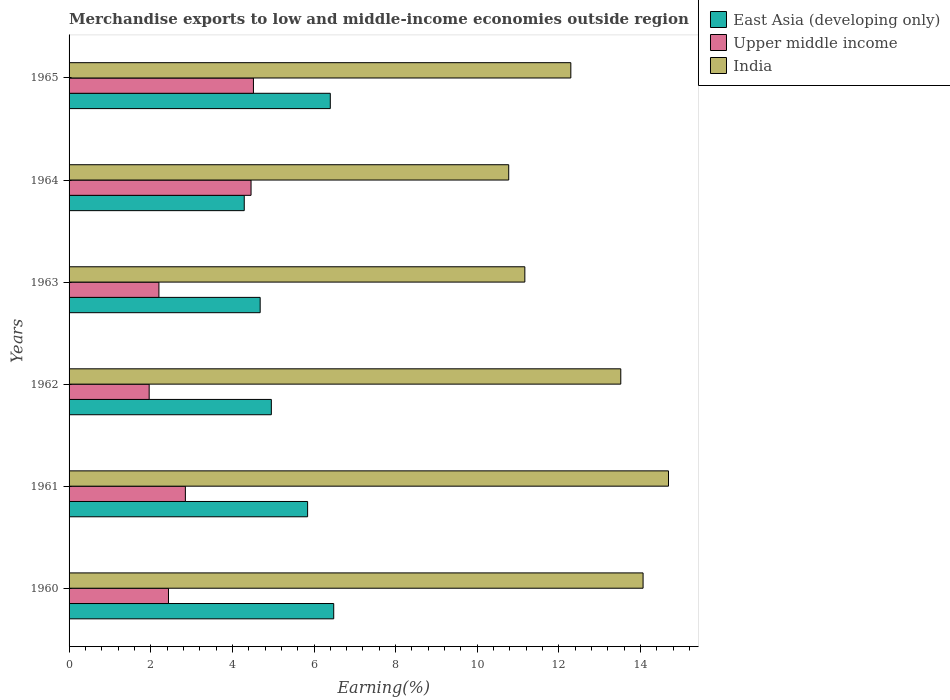How many groups of bars are there?
Offer a terse response. 6. Are the number of bars per tick equal to the number of legend labels?
Provide a succinct answer. Yes. How many bars are there on the 1st tick from the top?
Make the answer very short. 3. What is the label of the 1st group of bars from the top?
Provide a short and direct response. 1965. In how many cases, is the number of bars for a given year not equal to the number of legend labels?
Keep it short and to the point. 0. What is the percentage of amount earned from merchandise exports in Upper middle income in 1962?
Make the answer very short. 1.96. Across all years, what is the maximum percentage of amount earned from merchandise exports in India?
Offer a very short reply. 14.68. Across all years, what is the minimum percentage of amount earned from merchandise exports in Upper middle income?
Keep it short and to the point. 1.96. What is the total percentage of amount earned from merchandise exports in India in the graph?
Offer a terse response. 76.49. What is the difference between the percentage of amount earned from merchandise exports in India in 1962 and that in 1965?
Your answer should be compact. 1.22. What is the difference between the percentage of amount earned from merchandise exports in East Asia (developing only) in 1961 and the percentage of amount earned from merchandise exports in Upper middle income in 1960?
Ensure brevity in your answer.  3.41. What is the average percentage of amount earned from merchandise exports in East Asia (developing only) per year?
Offer a terse response. 5.44. In the year 1965, what is the difference between the percentage of amount earned from merchandise exports in India and percentage of amount earned from merchandise exports in Upper middle income?
Offer a terse response. 7.78. What is the ratio of the percentage of amount earned from merchandise exports in East Asia (developing only) in 1964 to that in 1965?
Provide a short and direct response. 0.67. What is the difference between the highest and the second highest percentage of amount earned from merchandise exports in East Asia (developing only)?
Provide a short and direct response. 0.08. What is the difference between the highest and the lowest percentage of amount earned from merchandise exports in Upper middle income?
Make the answer very short. 2.55. Is the sum of the percentage of amount earned from merchandise exports in Upper middle income in 1960 and 1962 greater than the maximum percentage of amount earned from merchandise exports in India across all years?
Your response must be concise. No. What does the 2nd bar from the top in 1961 represents?
Give a very brief answer. Upper middle income. What does the 1st bar from the bottom in 1960 represents?
Your response must be concise. East Asia (developing only). How many years are there in the graph?
Your answer should be very brief. 6. Does the graph contain grids?
Provide a short and direct response. No. Where does the legend appear in the graph?
Make the answer very short. Top right. How are the legend labels stacked?
Give a very brief answer. Vertical. What is the title of the graph?
Offer a terse response. Merchandise exports to low and middle-income economies outside region. What is the label or title of the X-axis?
Your response must be concise. Earning(%). What is the label or title of the Y-axis?
Your answer should be very brief. Years. What is the Earning(%) in East Asia (developing only) in 1960?
Provide a succinct answer. 6.48. What is the Earning(%) in Upper middle income in 1960?
Give a very brief answer. 2.44. What is the Earning(%) in India in 1960?
Give a very brief answer. 14.06. What is the Earning(%) in East Asia (developing only) in 1961?
Keep it short and to the point. 5.84. What is the Earning(%) in Upper middle income in 1961?
Your response must be concise. 2.85. What is the Earning(%) of India in 1961?
Offer a very short reply. 14.68. What is the Earning(%) in East Asia (developing only) in 1962?
Your answer should be very brief. 4.96. What is the Earning(%) in Upper middle income in 1962?
Offer a terse response. 1.96. What is the Earning(%) of India in 1962?
Ensure brevity in your answer.  13.52. What is the Earning(%) in East Asia (developing only) in 1963?
Provide a short and direct response. 4.68. What is the Earning(%) of Upper middle income in 1963?
Your answer should be very brief. 2.2. What is the Earning(%) of India in 1963?
Make the answer very short. 11.17. What is the Earning(%) in East Asia (developing only) in 1964?
Offer a very short reply. 4.29. What is the Earning(%) in Upper middle income in 1964?
Your answer should be compact. 4.46. What is the Earning(%) in India in 1964?
Ensure brevity in your answer.  10.77. What is the Earning(%) of East Asia (developing only) in 1965?
Offer a terse response. 6.4. What is the Earning(%) of Upper middle income in 1965?
Give a very brief answer. 4.52. What is the Earning(%) in India in 1965?
Offer a terse response. 12.29. Across all years, what is the maximum Earning(%) of East Asia (developing only)?
Your answer should be compact. 6.48. Across all years, what is the maximum Earning(%) in Upper middle income?
Provide a short and direct response. 4.52. Across all years, what is the maximum Earning(%) of India?
Your answer should be compact. 14.68. Across all years, what is the minimum Earning(%) of East Asia (developing only)?
Provide a succinct answer. 4.29. Across all years, what is the minimum Earning(%) in Upper middle income?
Give a very brief answer. 1.96. Across all years, what is the minimum Earning(%) in India?
Your answer should be compact. 10.77. What is the total Earning(%) of East Asia (developing only) in the graph?
Make the answer very short. 32.65. What is the total Earning(%) of Upper middle income in the graph?
Keep it short and to the point. 18.42. What is the total Earning(%) of India in the graph?
Your answer should be very brief. 76.49. What is the difference between the Earning(%) of East Asia (developing only) in 1960 and that in 1961?
Offer a very short reply. 0.64. What is the difference between the Earning(%) of Upper middle income in 1960 and that in 1961?
Offer a very short reply. -0.41. What is the difference between the Earning(%) of India in 1960 and that in 1961?
Offer a terse response. -0.62. What is the difference between the Earning(%) of East Asia (developing only) in 1960 and that in 1962?
Offer a very short reply. 1.53. What is the difference between the Earning(%) in Upper middle income in 1960 and that in 1962?
Offer a terse response. 0.47. What is the difference between the Earning(%) in India in 1960 and that in 1962?
Make the answer very short. 0.55. What is the difference between the Earning(%) of East Asia (developing only) in 1960 and that in 1963?
Make the answer very short. 1.8. What is the difference between the Earning(%) of Upper middle income in 1960 and that in 1963?
Ensure brevity in your answer.  0.23. What is the difference between the Earning(%) in India in 1960 and that in 1963?
Your answer should be compact. 2.9. What is the difference between the Earning(%) of East Asia (developing only) in 1960 and that in 1964?
Ensure brevity in your answer.  2.19. What is the difference between the Earning(%) of Upper middle income in 1960 and that in 1964?
Your answer should be compact. -2.02. What is the difference between the Earning(%) of India in 1960 and that in 1964?
Your response must be concise. 3.29. What is the difference between the Earning(%) in East Asia (developing only) in 1960 and that in 1965?
Ensure brevity in your answer.  0.08. What is the difference between the Earning(%) of Upper middle income in 1960 and that in 1965?
Your answer should be very brief. -2.08. What is the difference between the Earning(%) in India in 1960 and that in 1965?
Keep it short and to the point. 1.77. What is the difference between the Earning(%) in East Asia (developing only) in 1961 and that in 1962?
Make the answer very short. 0.89. What is the difference between the Earning(%) of Upper middle income in 1961 and that in 1962?
Give a very brief answer. 0.89. What is the difference between the Earning(%) in India in 1961 and that in 1962?
Offer a very short reply. 1.17. What is the difference between the Earning(%) in East Asia (developing only) in 1961 and that in 1963?
Offer a terse response. 1.16. What is the difference between the Earning(%) in Upper middle income in 1961 and that in 1963?
Your answer should be compact. 0.65. What is the difference between the Earning(%) in India in 1961 and that in 1963?
Offer a very short reply. 3.52. What is the difference between the Earning(%) in East Asia (developing only) in 1961 and that in 1964?
Offer a very short reply. 1.55. What is the difference between the Earning(%) in Upper middle income in 1961 and that in 1964?
Provide a succinct answer. -1.61. What is the difference between the Earning(%) in India in 1961 and that in 1964?
Your answer should be very brief. 3.91. What is the difference between the Earning(%) of East Asia (developing only) in 1961 and that in 1965?
Your answer should be very brief. -0.56. What is the difference between the Earning(%) of Upper middle income in 1961 and that in 1965?
Provide a short and direct response. -1.67. What is the difference between the Earning(%) in India in 1961 and that in 1965?
Your answer should be very brief. 2.39. What is the difference between the Earning(%) in East Asia (developing only) in 1962 and that in 1963?
Ensure brevity in your answer.  0.27. What is the difference between the Earning(%) in Upper middle income in 1962 and that in 1963?
Your answer should be very brief. -0.24. What is the difference between the Earning(%) of India in 1962 and that in 1963?
Give a very brief answer. 2.35. What is the difference between the Earning(%) of East Asia (developing only) in 1962 and that in 1964?
Provide a short and direct response. 0.66. What is the difference between the Earning(%) of Upper middle income in 1962 and that in 1964?
Give a very brief answer. -2.5. What is the difference between the Earning(%) of India in 1962 and that in 1964?
Give a very brief answer. 2.75. What is the difference between the Earning(%) in East Asia (developing only) in 1962 and that in 1965?
Make the answer very short. -1.44. What is the difference between the Earning(%) of Upper middle income in 1962 and that in 1965?
Your answer should be very brief. -2.55. What is the difference between the Earning(%) in India in 1962 and that in 1965?
Make the answer very short. 1.22. What is the difference between the Earning(%) of East Asia (developing only) in 1963 and that in 1964?
Keep it short and to the point. 0.39. What is the difference between the Earning(%) of Upper middle income in 1963 and that in 1964?
Your response must be concise. -2.26. What is the difference between the Earning(%) of India in 1963 and that in 1964?
Make the answer very short. 0.4. What is the difference between the Earning(%) of East Asia (developing only) in 1963 and that in 1965?
Provide a short and direct response. -1.72. What is the difference between the Earning(%) of Upper middle income in 1963 and that in 1965?
Provide a succinct answer. -2.32. What is the difference between the Earning(%) of India in 1963 and that in 1965?
Provide a succinct answer. -1.13. What is the difference between the Earning(%) of East Asia (developing only) in 1964 and that in 1965?
Offer a very short reply. -2.11. What is the difference between the Earning(%) in Upper middle income in 1964 and that in 1965?
Your answer should be compact. -0.06. What is the difference between the Earning(%) in India in 1964 and that in 1965?
Ensure brevity in your answer.  -1.52. What is the difference between the Earning(%) of East Asia (developing only) in 1960 and the Earning(%) of Upper middle income in 1961?
Offer a very short reply. 3.63. What is the difference between the Earning(%) of East Asia (developing only) in 1960 and the Earning(%) of India in 1961?
Your answer should be very brief. -8.2. What is the difference between the Earning(%) in Upper middle income in 1960 and the Earning(%) in India in 1961?
Keep it short and to the point. -12.25. What is the difference between the Earning(%) in East Asia (developing only) in 1960 and the Earning(%) in Upper middle income in 1962?
Provide a succinct answer. 4.52. What is the difference between the Earning(%) in East Asia (developing only) in 1960 and the Earning(%) in India in 1962?
Give a very brief answer. -7.03. What is the difference between the Earning(%) in Upper middle income in 1960 and the Earning(%) in India in 1962?
Offer a very short reply. -11.08. What is the difference between the Earning(%) of East Asia (developing only) in 1960 and the Earning(%) of Upper middle income in 1963?
Offer a terse response. 4.28. What is the difference between the Earning(%) in East Asia (developing only) in 1960 and the Earning(%) in India in 1963?
Make the answer very short. -4.68. What is the difference between the Earning(%) in Upper middle income in 1960 and the Earning(%) in India in 1963?
Make the answer very short. -8.73. What is the difference between the Earning(%) in East Asia (developing only) in 1960 and the Earning(%) in Upper middle income in 1964?
Offer a very short reply. 2.03. What is the difference between the Earning(%) of East Asia (developing only) in 1960 and the Earning(%) of India in 1964?
Give a very brief answer. -4.29. What is the difference between the Earning(%) of Upper middle income in 1960 and the Earning(%) of India in 1964?
Offer a terse response. -8.33. What is the difference between the Earning(%) of East Asia (developing only) in 1960 and the Earning(%) of Upper middle income in 1965?
Offer a terse response. 1.97. What is the difference between the Earning(%) in East Asia (developing only) in 1960 and the Earning(%) in India in 1965?
Make the answer very short. -5.81. What is the difference between the Earning(%) of Upper middle income in 1960 and the Earning(%) of India in 1965?
Give a very brief answer. -9.86. What is the difference between the Earning(%) of East Asia (developing only) in 1961 and the Earning(%) of Upper middle income in 1962?
Your response must be concise. 3.88. What is the difference between the Earning(%) of East Asia (developing only) in 1961 and the Earning(%) of India in 1962?
Keep it short and to the point. -7.67. What is the difference between the Earning(%) of Upper middle income in 1961 and the Earning(%) of India in 1962?
Offer a terse response. -10.67. What is the difference between the Earning(%) in East Asia (developing only) in 1961 and the Earning(%) in Upper middle income in 1963?
Provide a short and direct response. 3.64. What is the difference between the Earning(%) in East Asia (developing only) in 1961 and the Earning(%) in India in 1963?
Your answer should be very brief. -5.32. What is the difference between the Earning(%) of Upper middle income in 1961 and the Earning(%) of India in 1963?
Keep it short and to the point. -8.32. What is the difference between the Earning(%) in East Asia (developing only) in 1961 and the Earning(%) in Upper middle income in 1964?
Keep it short and to the point. 1.39. What is the difference between the Earning(%) in East Asia (developing only) in 1961 and the Earning(%) in India in 1964?
Offer a very short reply. -4.93. What is the difference between the Earning(%) in Upper middle income in 1961 and the Earning(%) in India in 1964?
Ensure brevity in your answer.  -7.92. What is the difference between the Earning(%) in East Asia (developing only) in 1961 and the Earning(%) in Upper middle income in 1965?
Provide a succinct answer. 1.33. What is the difference between the Earning(%) in East Asia (developing only) in 1961 and the Earning(%) in India in 1965?
Provide a short and direct response. -6.45. What is the difference between the Earning(%) of Upper middle income in 1961 and the Earning(%) of India in 1965?
Provide a short and direct response. -9.44. What is the difference between the Earning(%) in East Asia (developing only) in 1962 and the Earning(%) in Upper middle income in 1963?
Give a very brief answer. 2.75. What is the difference between the Earning(%) in East Asia (developing only) in 1962 and the Earning(%) in India in 1963?
Your response must be concise. -6.21. What is the difference between the Earning(%) of Upper middle income in 1962 and the Earning(%) of India in 1963?
Your response must be concise. -9.2. What is the difference between the Earning(%) of East Asia (developing only) in 1962 and the Earning(%) of Upper middle income in 1964?
Give a very brief answer. 0.5. What is the difference between the Earning(%) of East Asia (developing only) in 1962 and the Earning(%) of India in 1964?
Offer a very short reply. -5.82. What is the difference between the Earning(%) of Upper middle income in 1962 and the Earning(%) of India in 1964?
Provide a succinct answer. -8.81. What is the difference between the Earning(%) of East Asia (developing only) in 1962 and the Earning(%) of Upper middle income in 1965?
Provide a short and direct response. 0.44. What is the difference between the Earning(%) in East Asia (developing only) in 1962 and the Earning(%) in India in 1965?
Offer a terse response. -7.34. What is the difference between the Earning(%) of Upper middle income in 1962 and the Earning(%) of India in 1965?
Provide a short and direct response. -10.33. What is the difference between the Earning(%) of East Asia (developing only) in 1963 and the Earning(%) of Upper middle income in 1964?
Give a very brief answer. 0.22. What is the difference between the Earning(%) in East Asia (developing only) in 1963 and the Earning(%) in India in 1964?
Make the answer very short. -6.09. What is the difference between the Earning(%) of Upper middle income in 1963 and the Earning(%) of India in 1964?
Make the answer very short. -8.57. What is the difference between the Earning(%) in East Asia (developing only) in 1963 and the Earning(%) in Upper middle income in 1965?
Make the answer very short. 0.17. What is the difference between the Earning(%) of East Asia (developing only) in 1963 and the Earning(%) of India in 1965?
Provide a succinct answer. -7.61. What is the difference between the Earning(%) of Upper middle income in 1963 and the Earning(%) of India in 1965?
Offer a terse response. -10.09. What is the difference between the Earning(%) in East Asia (developing only) in 1964 and the Earning(%) in Upper middle income in 1965?
Offer a very short reply. -0.23. What is the difference between the Earning(%) in East Asia (developing only) in 1964 and the Earning(%) in India in 1965?
Your response must be concise. -8. What is the difference between the Earning(%) in Upper middle income in 1964 and the Earning(%) in India in 1965?
Make the answer very short. -7.83. What is the average Earning(%) of East Asia (developing only) per year?
Ensure brevity in your answer.  5.44. What is the average Earning(%) of Upper middle income per year?
Your answer should be compact. 3.07. What is the average Earning(%) of India per year?
Your response must be concise. 12.75. In the year 1960, what is the difference between the Earning(%) in East Asia (developing only) and Earning(%) in Upper middle income?
Your answer should be compact. 4.05. In the year 1960, what is the difference between the Earning(%) in East Asia (developing only) and Earning(%) in India?
Offer a very short reply. -7.58. In the year 1960, what is the difference between the Earning(%) in Upper middle income and Earning(%) in India?
Provide a succinct answer. -11.63. In the year 1961, what is the difference between the Earning(%) of East Asia (developing only) and Earning(%) of Upper middle income?
Your answer should be very brief. 2.99. In the year 1961, what is the difference between the Earning(%) of East Asia (developing only) and Earning(%) of India?
Keep it short and to the point. -8.84. In the year 1961, what is the difference between the Earning(%) of Upper middle income and Earning(%) of India?
Your answer should be very brief. -11.84. In the year 1962, what is the difference between the Earning(%) in East Asia (developing only) and Earning(%) in Upper middle income?
Provide a short and direct response. 2.99. In the year 1962, what is the difference between the Earning(%) of East Asia (developing only) and Earning(%) of India?
Ensure brevity in your answer.  -8.56. In the year 1962, what is the difference between the Earning(%) of Upper middle income and Earning(%) of India?
Make the answer very short. -11.55. In the year 1963, what is the difference between the Earning(%) of East Asia (developing only) and Earning(%) of Upper middle income?
Offer a terse response. 2.48. In the year 1963, what is the difference between the Earning(%) in East Asia (developing only) and Earning(%) in India?
Offer a terse response. -6.48. In the year 1963, what is the difference between the Earning(%) in Upper middle income and Earning(%) in India?
Your response must be concise. -8.96. In the year 1964, what is the difference between the Earning(%) of East Asia (developing only) and Earning(%) of India?
Offer a terse response. -6.48. In the year 1964, what is the difference between the Earning(%) of Upper middle income and Earning(%) of India?
Your answer should be compact. -6.31. In the year 1965, what is the difference between the Earning(%) in East Asia (developing only) and Earning(%) in Upper middle income?
Make the answer very short. 1.88. In the year 1965, what is the difference between the Earning(%) in East Asia (developing only) and Earning(%) in India?
Ensure brevity in your answer.  -5.89. In the year 1965, what is the difference between the Earning(%) of Upper middle income and Earning(%) of India?
Your answer should be very brief. -7.78. What is the ratio of the Earning(%) in East Asia (developing only) in 1960 to that in 1961?
Provide a succinct answer. 1.11. What is the ratio of the Earning(%) of Upper middle income in 1960 to that in 1961?
Ensure brevity in your answer.  0.85. What is the ratio of the Earning(%) in India in 1960 to that in 1961?
Ensure brevity in your answer.  0.96. What is the ratio of the Earning(%) of East Asia (developing only) in 1960 to that in 1962?
Give a very brief answer. 1.31. What is the ratio of the Earning(%) in Upper middle income in 1960 to that in 1962?
Ensure brevity in your answer.  1.24. What is the ratio of the Earning(%) of India in 1960 to that in 1962?
Give a very brief answer. 1.04. What is the ratio of the Earning(%) in East Asia (developing only) in 1960 to that in 1963?
Your answer should be compact. 1.38. What is the ratio of the Earning(%) in Upper middle income in 1960 to that in 1963?
Keep it short and to the point. 1.11. What is the ratio of the Earning(%) of India in 1960 to that in 1963?
Provide a short and direct response. 1.26. What is the ratio of the Earning(%) of East Asia (developing only) in 1960 to that in 1964?
Provide a short and direct response. 1.51. What is the ratio of the Earning(%) of Upper middle income in 1960 to that in 1964?
Your answer should be compact. 0.55. What is the ratio of the Earning(%) of India in 1960 to that in 1964?
Your response must be concise. 1.31. What is the ratio of the Earning(%) of East Asia (developing only) in 1960 to that in 1965?
Your response must be concise. 1.01. What is the ratio of the Earning(%) in Upper middle income in 1960 to that in 1965?
Provide a short and direct response. 0.54. What is the ratio of the Earning(%) of India in 1960 to that in 1965?
Give a very brief answer. 1.14. What is the ratio of the Earning(%) in East Asia (developing only) in 1961 to that in 1962?
Provide a succinct answer. 1.18. What is the ratio of the Earning(%) in Upper middle income in 1961 to that in 1962?
Keep it short and to the point. 1.45. What is the ratio of the Earning(%) in India in 1961 to that in 1962?
Provide a succinct answer. 1.09. What is the ratio of the Earning(%) in East Asia (developing only) in 1961 to that in 1963?
Give a very brief answer. 1.25. What is the ratio of the Earning(%) in Upper middle income in 1961 to that in 1963?
Ensure brevity in your answer.  1.29. What is the ratio of the Earning(%) in India in 1961 to that in 1963?
Keep it short and to the point. 1.32. What is the ratio of the Earning(%) of East Asia (developing only) in 1961 to that in 1964?
Provide a short and direct response. 1.36. What is the ratio of the Earning(%) in Upper middle income in 1961 to that in 1964?
Ensure brevity in your answer.  0.64. What is the ratio of the Earning(%) of India in 1961 to that in 1964?
Your answer should be very brief. 1.36. What is the ratio of the Earning(%) of East Asia (developing only) in 1961 to that in 1965?
Ensure brevity in your answer.  0.91. What is the ratio of the Earning(%) in Upper middle income in 1961 to that in 1965?
Give a very brief answer. 0.63. What is the ratio of the Earning(%) in India in 1961 to that in 1965?
Your answer should be very brief. 1.19. What is the ratio of the Earning(%) in East Asia (developing only) in 1962 to that in 1963?
Provide a succinct answer. 1.06. What is the ratio of the Earning(%) of Upper middle income in 1962 to that in 1963?
Provide a short and direct response. 0.89. What is the ratio of the Earning(%) in India in 1962 to that in 1963?
Make the answer very short. 1.21. What is the ratio of the Earning(%) in East Asia (developing only) in 1962 to that in 1964?
Give a very brief answer. 1.15. What is the ratio of the Earning(%) of Upper middle income in 1962 to that in 1964?
Give a very brief answer. 0.44. What is the ratio of the Earning(%) in India in 1962 to that in 1964?
Offer a very short reply. 1.25. What is the ratio of the Earning(%) in East Asia (developing only) in 1962 to that in 1965?
Your answer should be compact. 0.77. What is the ratio of the Earning(%) of Upper middle income in 1962 to that in 1965?
Make the answer very short. 0.43. What is the ratio of the Earning(%) in India in 1962 to that in 1965?
Your answer should be very brief. 1.1. What is the ratio of the Earning(%) of East Asia (developing only) in 1963 to that in 1964?
Provide a short and direct response. 1.09. What is the ratio of the Earning(%) in Upper middle income in 1963 to that in 1964?
Your response must be concise. 0.49. What is the ratio of the Earning(%) of India in 1963 to that in 1964?
Your answer should be very brief. 1.04. What is the ratio of the Earning(%) in East Asia (developing only) in 1963 to that in 1965?
Your answer should be compact. 0.73. What is the ratio of the Earning(%) in Upper middle income in 1963 to that in 1965?
Keep it short and to the point. 0.49. What is the ratio of the Earning(%) in India in 1963 to that in 1965?
Offer a very short reply. 0.91. What is the ratio of the Earning(%) in East Asia (developing only) in 1964 to that in 1965?
Offer a very short reply. 0.67. What is the ratio of the Earning(%) in Upper middle income in 1964 to that in 1965?
Ensure brevity in your answer.  0.99. What is the ratio of the Earning(%) in India in 1964 to that in 1965?
Provide a short and direct response. 0.88. What is the difference between the highest and the second highest Earning(%) in East Asia (developing only)?
Make the answer very short. 0.08. What is the difference between the highest and the second highest Earning(%) in Upper middle income?
Your answer should be compact. 0.06. What is the difference between the highest and the second highest Earning(%) of India?
Provide a succinct answer. 0.62. What is the difference between the highest and the lowest Earning(%) of East Asia (developing only)?
Make the answer very short. 2.19. What is the difference between the highest and the lowest Earning(%) in Upper middle income?
Ensure brevity in your answer.  2.55. What is the difference between the highest and the lowest Earning(%) in India?
Give a very brief answer. 3.91. 